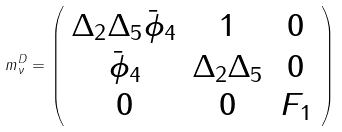<formula> <loc_0><loc_0><loc_500><loc_500>m _ { \nu } ^ { D } = \left ( \begin{array} { c c c } { { \Delta _ { 2 } \Delta _ { 5 } \bar { \phi } _ { 4 } } } & { 1 } & { 0 } \\ { { \bar { \phi } _ { 4 } } } & { { \Delta _ { 2 } \Delta _ { 5 } } } & { 0 } \\ { 0 } & { 0 } & { { F _ { 1 } } } \end{array} \right )</formula> 